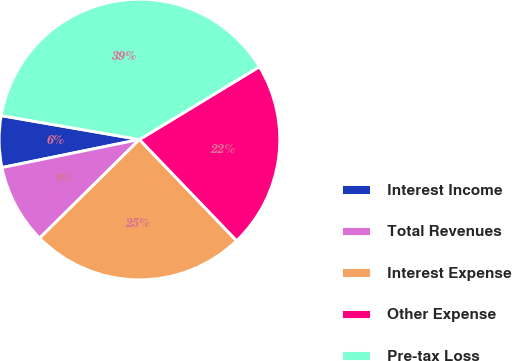Convert chart to OTSL. <chart><loc_0><loc_0><loc_500><loc_500><pie_chart><fcel>Interest Income<fcel>Total Revenues<fcel>Interest Expense<fcel>Other Expense<fcel>Pre-tax Loss<nl><fcel>5.93%<fcel>9.2%<fcel>24.77%<fcel>21.51%<fcel>38.59%<nl></chart> 